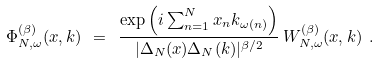Convert formula to latex. <formula><loc_0><loc_0><loc_500><loc_500>\Phi _ { N , \omega } ^ { ( \beta ) } ( x , k ) \ = \ \frac { \exp \left ( i \sum _ { n = 1 } ^ { N } x _ { n } k _ { \omega ( n ) } \right ) } { | \Delta _ { N } ( x ) \Delta _ { N } ( k ) | ^ { \beta / 2 } } \, W _ { N , \omega } ^ { ( \beta ) } ( x , k ) \ .</formula> 